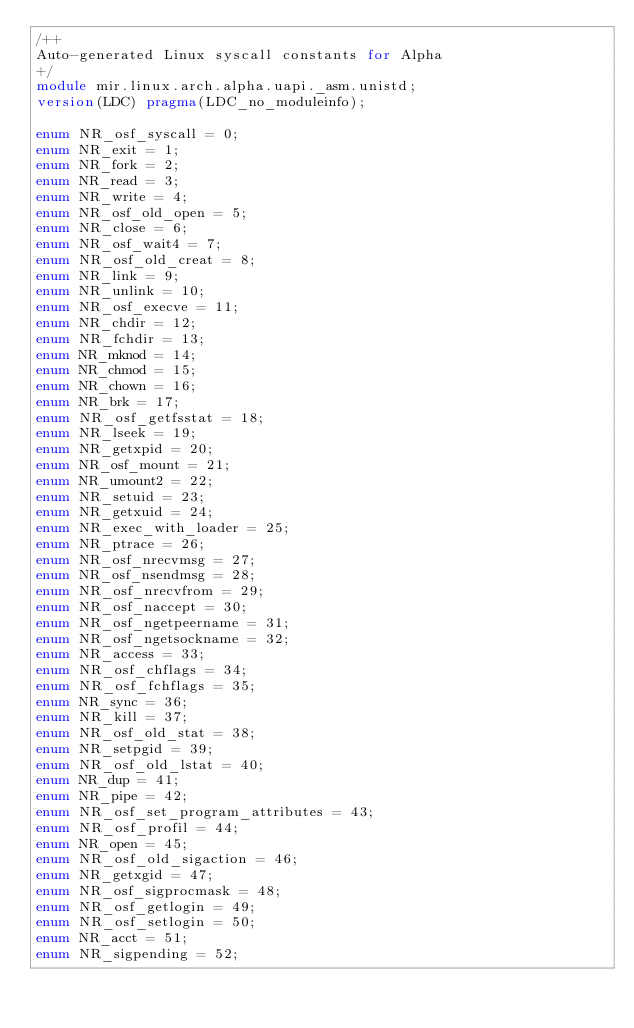Convert code to text. <code><loc_0><loc_0><loc_500><loc_500><_D_>/++
Auto-generated Linux syscall constants for Alpha
+/
module mir.linux.arch.alpha.uapi._asm.unistd;
version(LDC) pragma(LDC_no_moduleinfo);

enum NR_osf_syscall = 0;
enum NR_exit = 1;
enum NR_fork = 2;
enum NR_read = 3;
enum NR_write = 4;
enum NR_osf_old_open = 5;
enum NR_close = 6;
enum NR_osf_wait4 = 7;
enum NR_osf_old_creat = 8;
enum NR_link = 9;
enum NR_unlink = 10;
enum NR_osf_execve = 11;
enum NR_chdir = 12;
enum NR_fchdir = 13;
enum NR_mknod = 14;
enum NR_chmod = 15;
enum NR_chown = 16;
enum NR_brk = 17;
enum NR_osf_getfsstat = 18;
enum NR_lseek = 19;
enum NR_getxpid = 20;
enum NR_osf_mount = 21;
enum NR_umount2 = 22;
enum NR_setuid = 23;
enum NR_getxuid = 24;
enum NR_exec_with_loader = 25;
enum NR_ptrace = 26;
enum NR_osf_nrecvmsg = 27;
enum NR_osf_nsendmsg = 28;
enum NR_osf_nrecvfrom = 29;
enum NR_osf_naccept = 30;
enum NR_osf_ngetpeername = 31;
enum NR_osf_ngetsockname = 32;
enum NR_access = 33;
enum NR_osf_chflags = 34;
enum NR_osf_fchflags = 35;
enum NR_sync = 36;
enum NR_kill = 37;
enum NR_osf_old_stat = 38;
enum NR_setpgid = 39;
enum NR_osf_old_lstat = 40;
enum NR_dup = 41;
enum NR_pipe = 42;
enum NR_osf_set_program_attributes = 43;
enum NR_osf_profil = 44;
enum NR_open = 45;
enum NR_osf_old_sigaction = 46;
enum NR_getxgid = 47;
enum NR_osf_sigprocmask = 48;
enum NR_osf_getlogin = 49;
enum NR_osf_setlogin = 50;
enum NR_acct = 51;
enum NR_sigpending = 52;</code> 